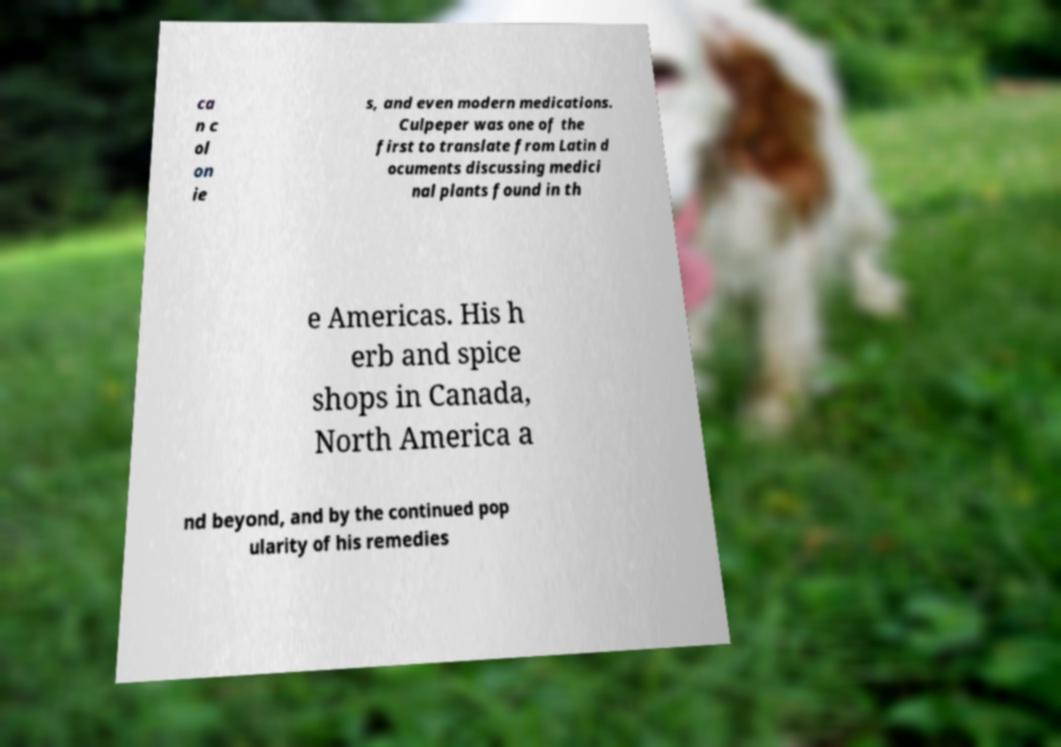Could you assist in decoding the text presented in this image and type it out clearly? ca n c ol on ie s, and even modern medications. Culpeper was one of the first to translate from Latin d ocuments discussing medici nal plants found in th e Americas. His h erb and spice shops in Canada, North America a nd beyond, and by the continued pop ularity of his remedies 